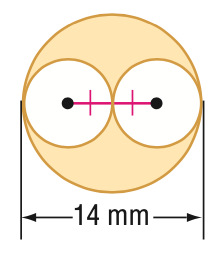Answer the mathemtical geometry problem and directly provide the correct option letter.
Question: Find the area of the shaded region. Round to the nearest tenth.
Choices: A: 38.5 B: 77.0 C: 115.5 D: 153.9 B 